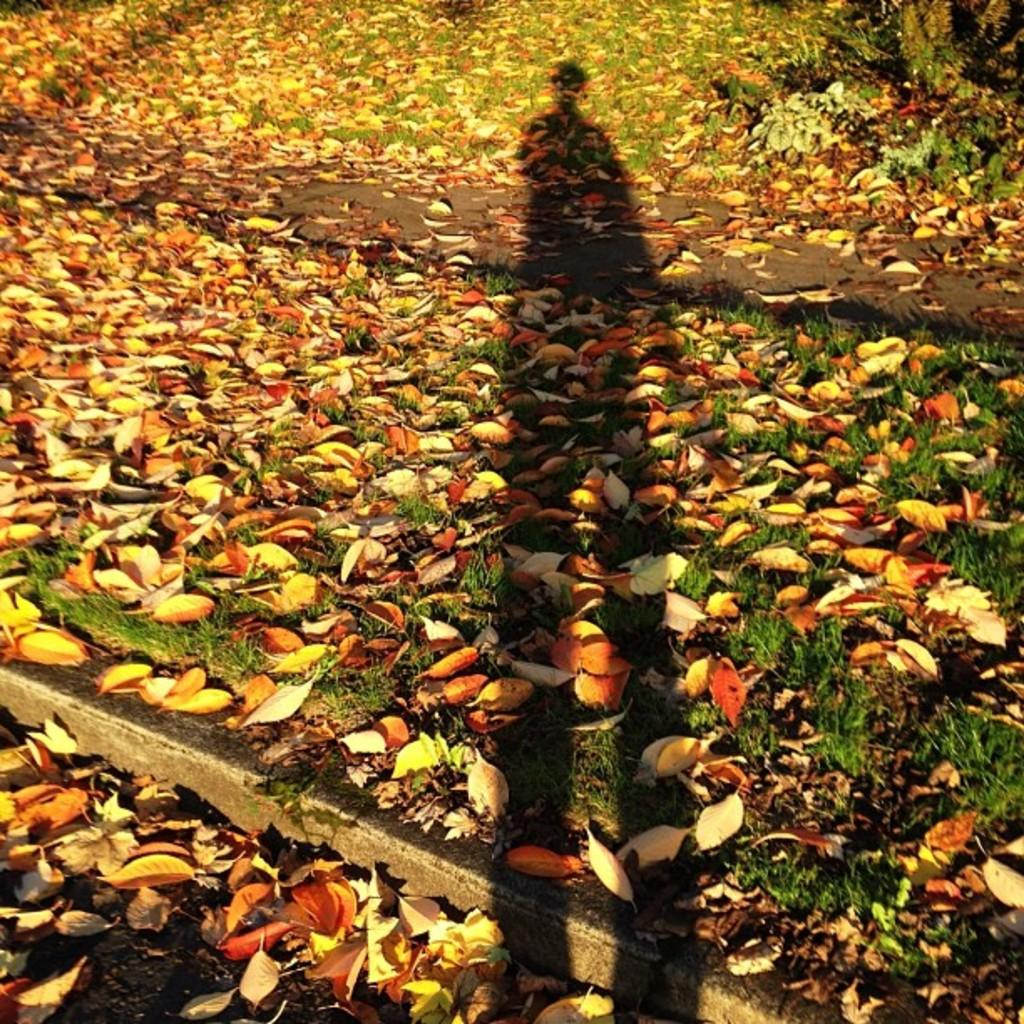What type of natural material can be seen in the image? There are dried leaves in the image. Can you describe any other element in the image? There is a shadow of a person on the ground in the image. What type of fruit is being displayed in the image? There is no fruit present in the image; it only features dried leaves and a shadow of a person. 